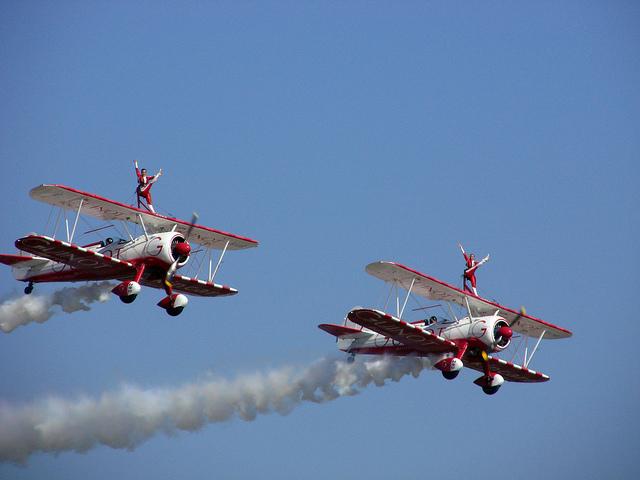What type of aircraft are these?
Quick response, please. Biplanes. What type of planes are these?
Quick response, please. Biplanes. What color are the people on top of the planes wearing?
Give a very brief answer. Red. What is being emitted from the backs of these planes?
Keep it brief. Smoke. What are the name of these planes?
Keep it brief. Biplanes. How many aircrafts are flying?
Be succinct. 2. Which planes are driven by propellers?
Quick response, please. Both. 